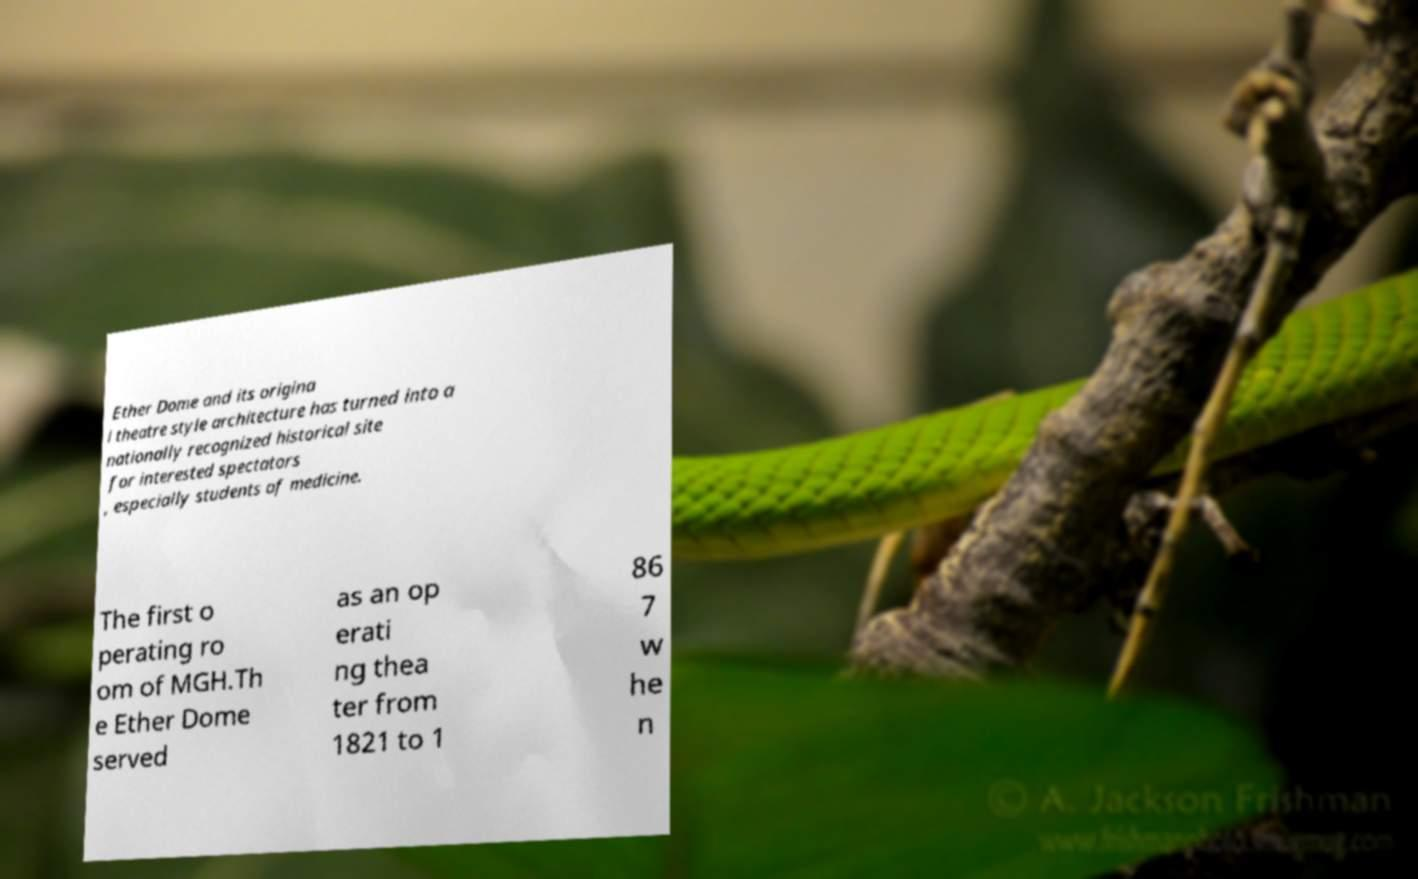Can you accurately transcribe the text from the provided image for me? Ether Dome and its origina l theatre style architecture has turned into a nationally recognized historical site for interested spectators , especially students of medicine. The first o perating ro om of MGH.Th e Ether Dome served as an op erati ng thea ter from 1821 to 1 86 7 w he n 